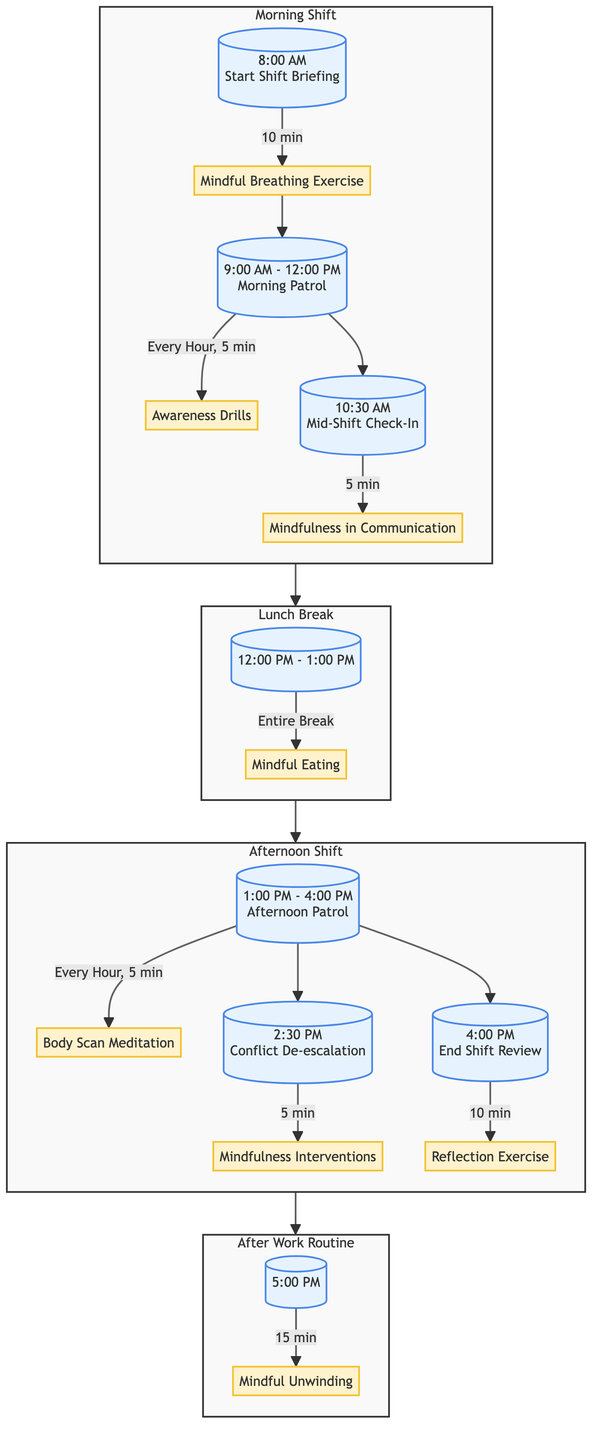What activity occurs at 8:00 AM? At 8:00 AM, the diagram indicates the "Start Shift Briefing" which is the time when officers begin their shift. The activity that follows is "Mindful Breathing Exercise" lasting for 10 minutes.
Answer: Mindful Breathing Exercise How long is the lunch break scheduled for? The segment labeled "Lunch Break" shows the time from 12:00 PM to 1:00 PM. This means the length of the lunch break is one hour.
Answer: 1 hour What is performed every hour during the morning patrol? According to the diagram, during the "Morning Patrol," officers perform "Awareness Drills" every hour for 5 minutes. This reflects the sequential activity planned during this time frame.
Answer: Awareness Drills What mindfulness practice is scheduled at 2:30 PM? The diagram shows that at 2:30 PM, there is a segment labeled "Conflict De-escalation" which incorporates "Mindfulness Interventions." This indicates that this specific mindfulness practice is designed to address conflict situations.
Answer: Mindfulness Interventions What follows the "End Shift Review"? After "End Shift Review," the diagram shows a progression to "After Work Routine." This signifies that these two segments are sequentially connected, illustrating the flow of activities.
Answer: After Work Routine What activity engages officers during the entire lunch break? The "Mindful Eating" activity is planned during the entire lunch break from 12:00 PM to 1:00 PM, encouraging officers to focus on their sensory experience while eating.
Answer: Mindful Eating How many mindfulness activities are there in the afternoon shift? The afternoon shift includes three mindfulness-related activities: "Body Scan Meditation," "Mindfulness Interventions," and "Reflection Exercise." By counting these, we confirm the total number of activities in this section.
Answer: 3 What is the duration of the "Mindful Unwinding" activity? The diagram clearly states that the "Mindful Unwinding" activity lasts for 15 minutes, indicating a prescribed duration for this unwinding practice.
Answer: 15 minutes What is the focus of the "Mid-Shift Check-In"? The "Mid-Shift Check-In" emphasizes the practice of "Mindfulness in Communication," which encourages officers to engage in active listening with colleagues or citizens.
Answer: Mindfulness in Communication 